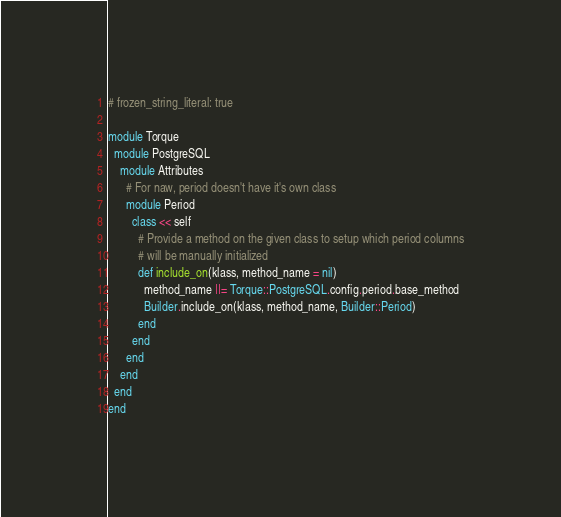<code> <loc_0><loc_0><loc_500><loc_500><_Ruby_># frozen_string_literal: true

module Torque
  module PostgreSQL
    module Attributes
      # For naw, period doesn't have it's own class
      module Period
        class << self
          # Provide a method on the given class to setup which period columns
          # will be manually initialized
          def include_on(klass, method_name = nil)
            method_name ||= Torque::PostgreSQL.config.period.base_method
            Builder.include_on(klass, method_name, Builder::Period)
          end
        end
      end
    end
  end
end
</code> 